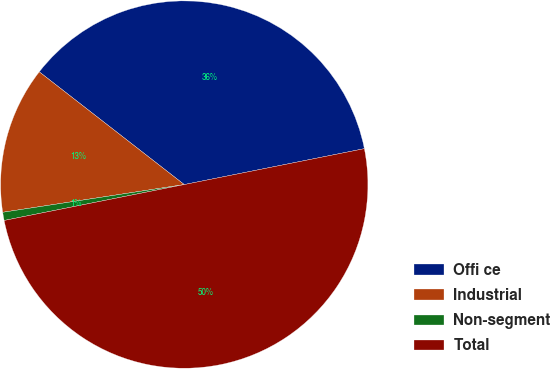<chart> <loc_0><loc_0><loc_500><loc_500><pie_chart><fcel>Offi ce<fcel>Industrial<fcel>Non-segment<fcel>Total<nl><fcel>36.35%<fcel>12.93%<fcel>0.72%<fcel>50.0%<nl></chart> 